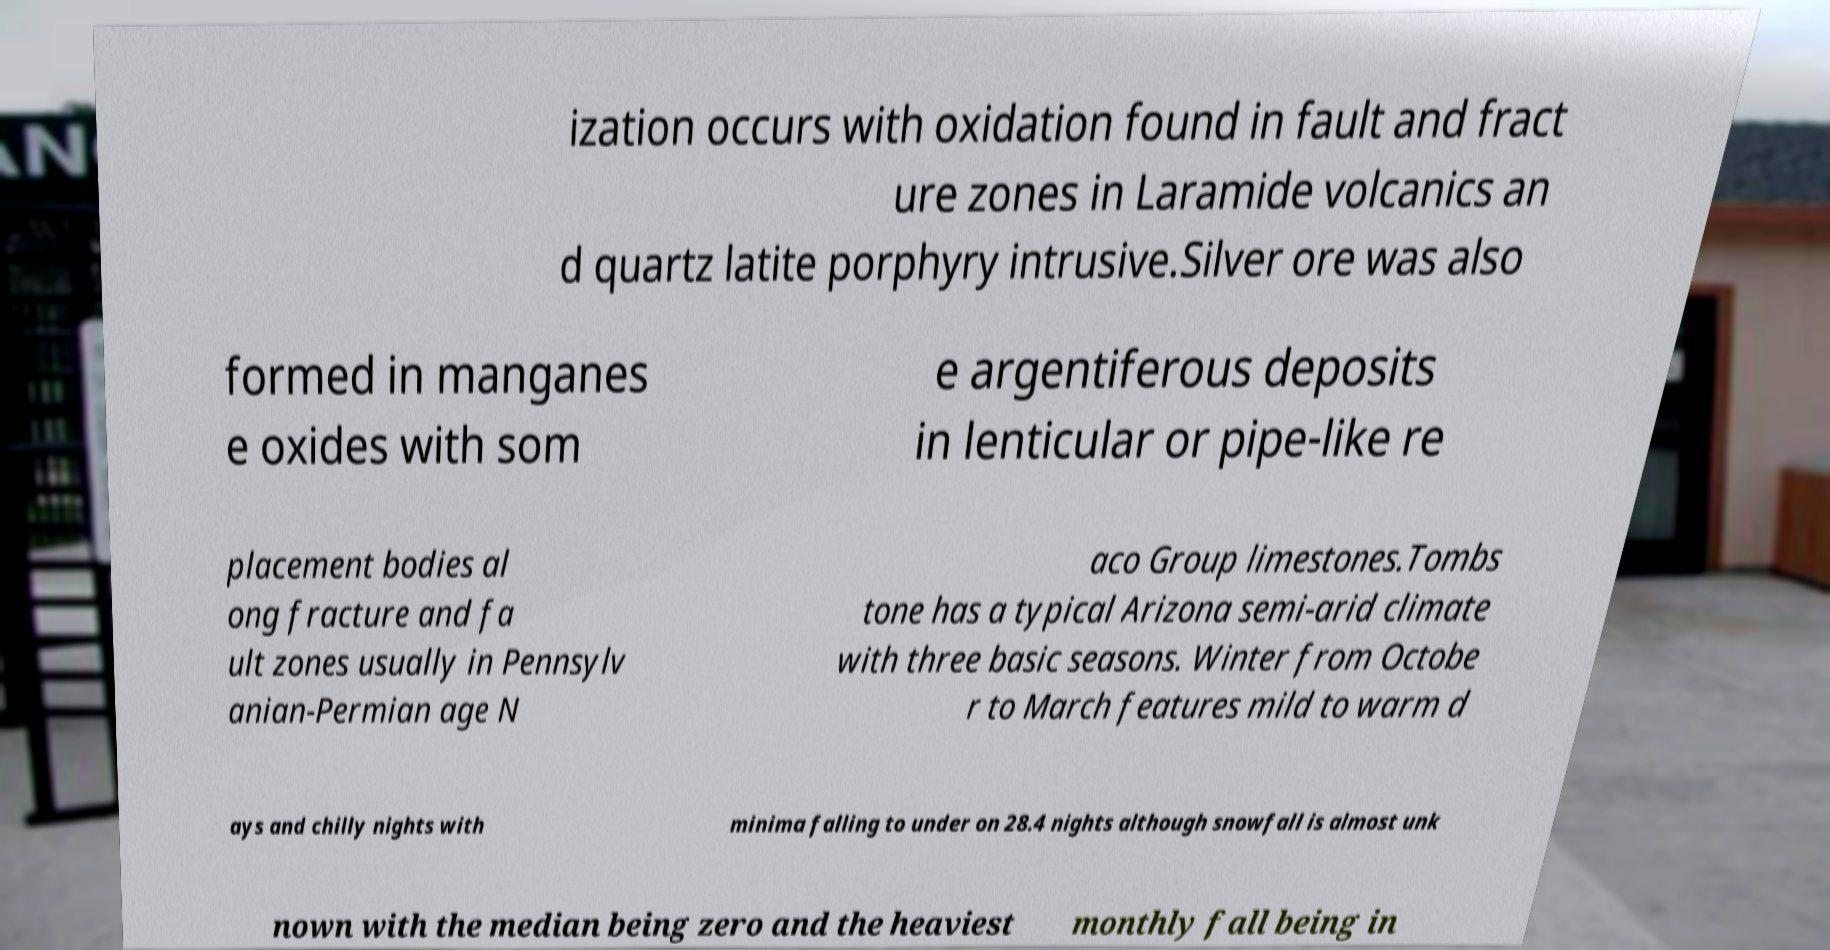Can you read and provide the text displayed in the image?This photo seems to have some interesting text. Can you extract and type it out for me? ization occurs with oxidation found in fault and fract ure zones in Laramide volcanics an d quartz latite porphyry intrusive.Silver ore was also formed in manganes e oxides with som e argentiferous deposits in lenticular or pipe-like re placement bodies al ong fracture and fa ult zones usually in Pennsylv anian-Permian age N aco Group limestones.Tombs tone has a typical Arizona semi-arid climate with three basic seasons. Winter from Octobe r to March features mild to warm d ays and chilly nights with minima falling to under on 28.4 nights although snowfall is almost unk nown with the median being zero and the heaviest monthly fall being in 